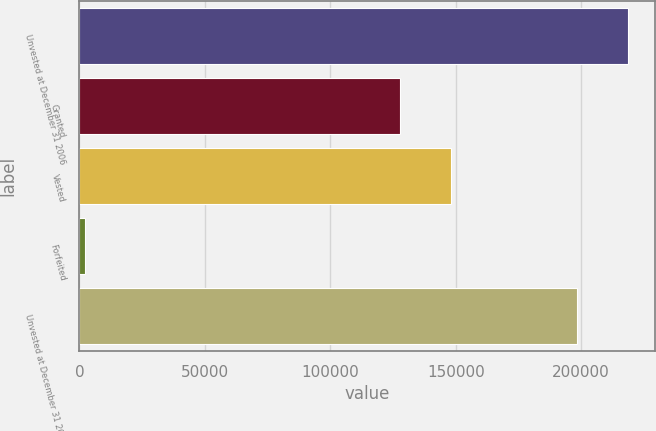Convert chart to OTSL. <chart><loc_0><loc_0><loc_500><loc_500><bar_chart><fcel>Unvested at December 31 2006<fcel>Granted<fcel>Vested<fcel>Forfeited<fcel>Unvested at December 31 2007<nl><fcel>218543<fcel>127867<fcel>148004<fcel>2326<fcel>198406<nl></chart> 